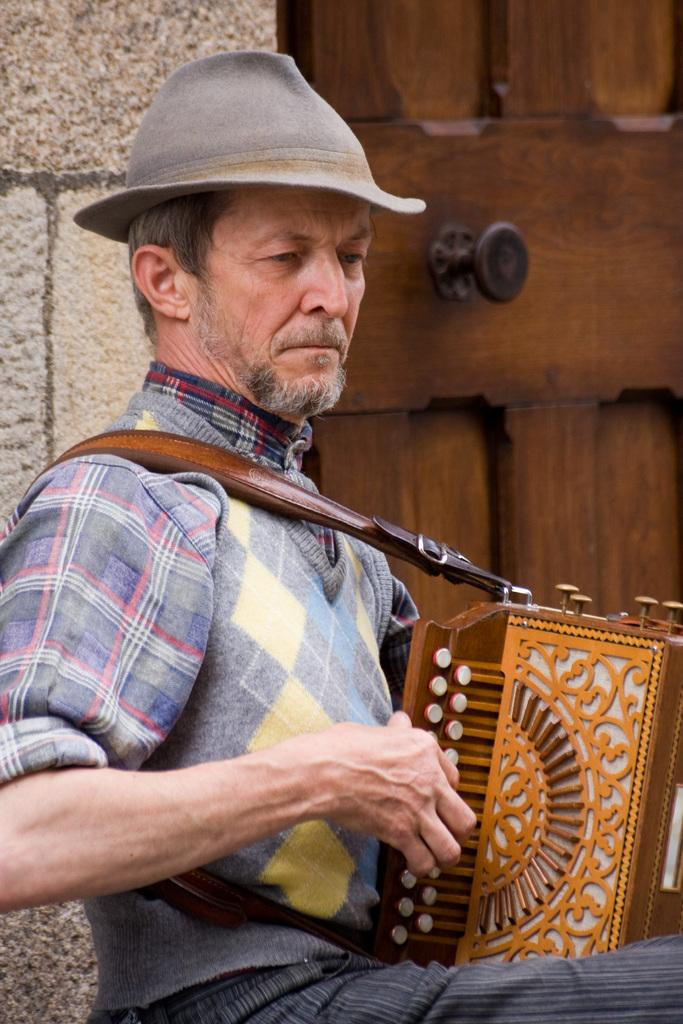What is the man in the image doing? The man is sitting in the image. What is the man holding in the image? The man is holding a musical instrument. Can you describe the man's attire in the image? The man is wearing a hat. What can be seen in the background of the image? There is a brown-colored door in the background of the image. What type of bird is perched on the man's shoulder in the image? There is no bird present in the image; the man is holding a musical instrument and wearing a hat. 